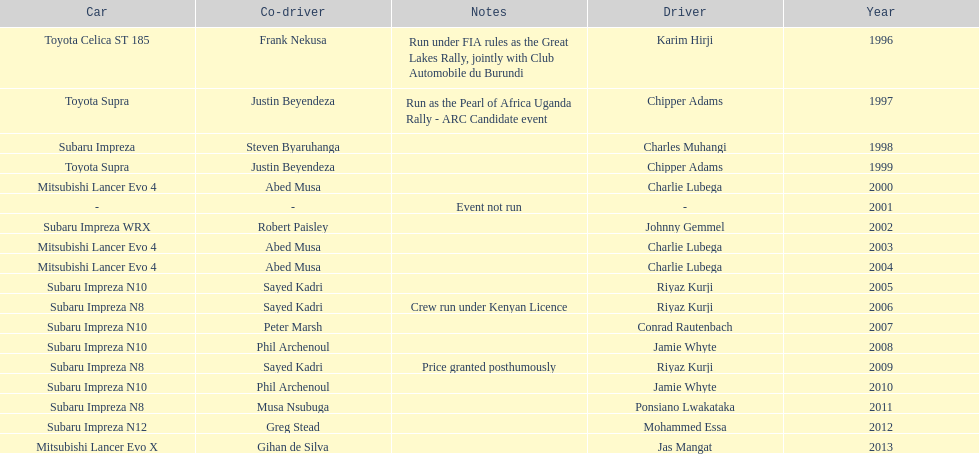What is the total number of times that the winning driver was driving a toyota supra? 2. 